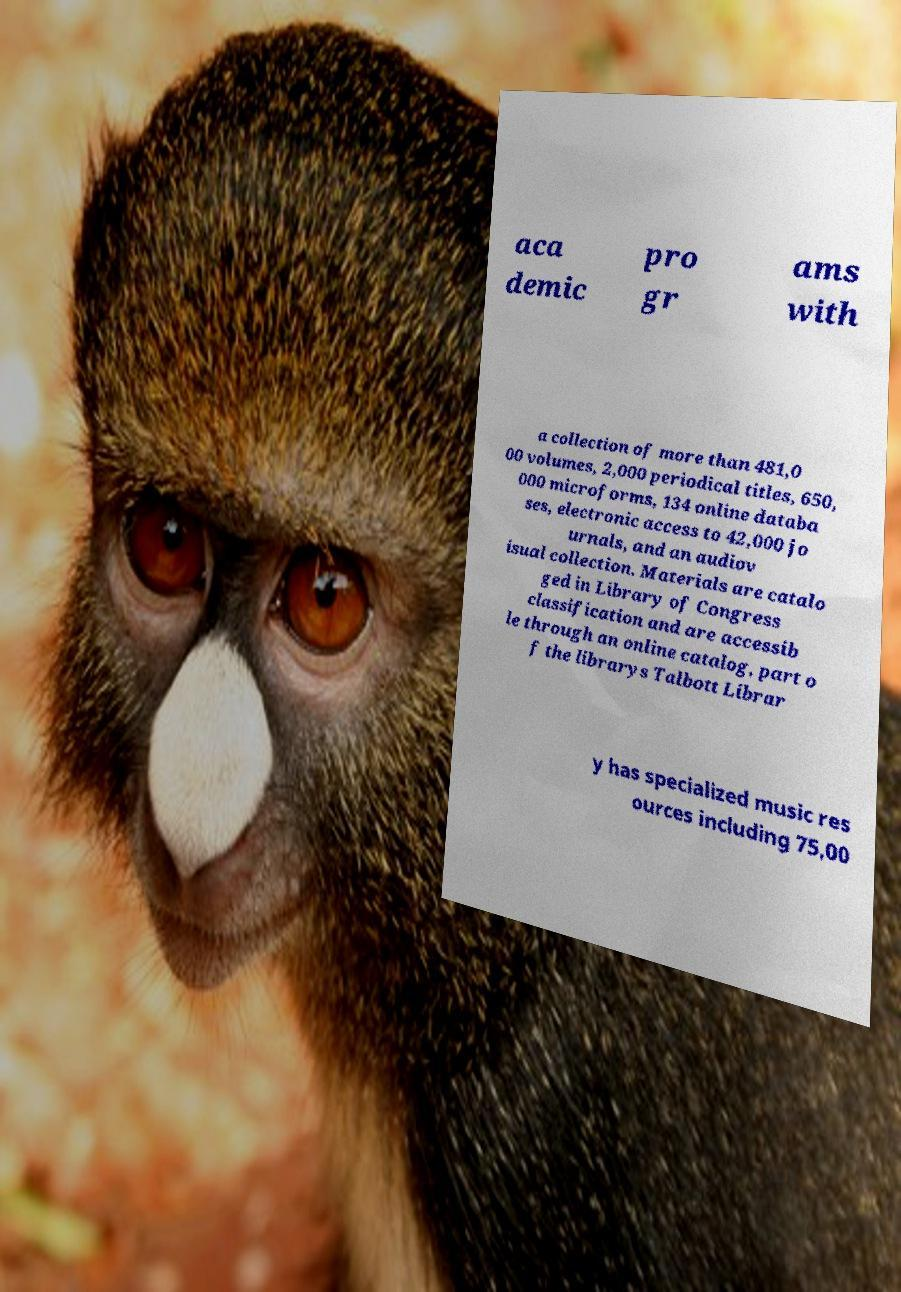Please identify and transcribe the text found in this image. aca demic pro gr ams with a collection of more than 481,0 00 volumes, 2,000 periodical titles, 650, 000 microforms, 134 online databa ses, electronic access to 42,000 jo urnals, and an audiov isual collection. Materials are catalo ged in Library of Congress classification and are accessib le through an online catalog, part o f the librarys Talbott Librar y has specialized music res ources including 75,00 